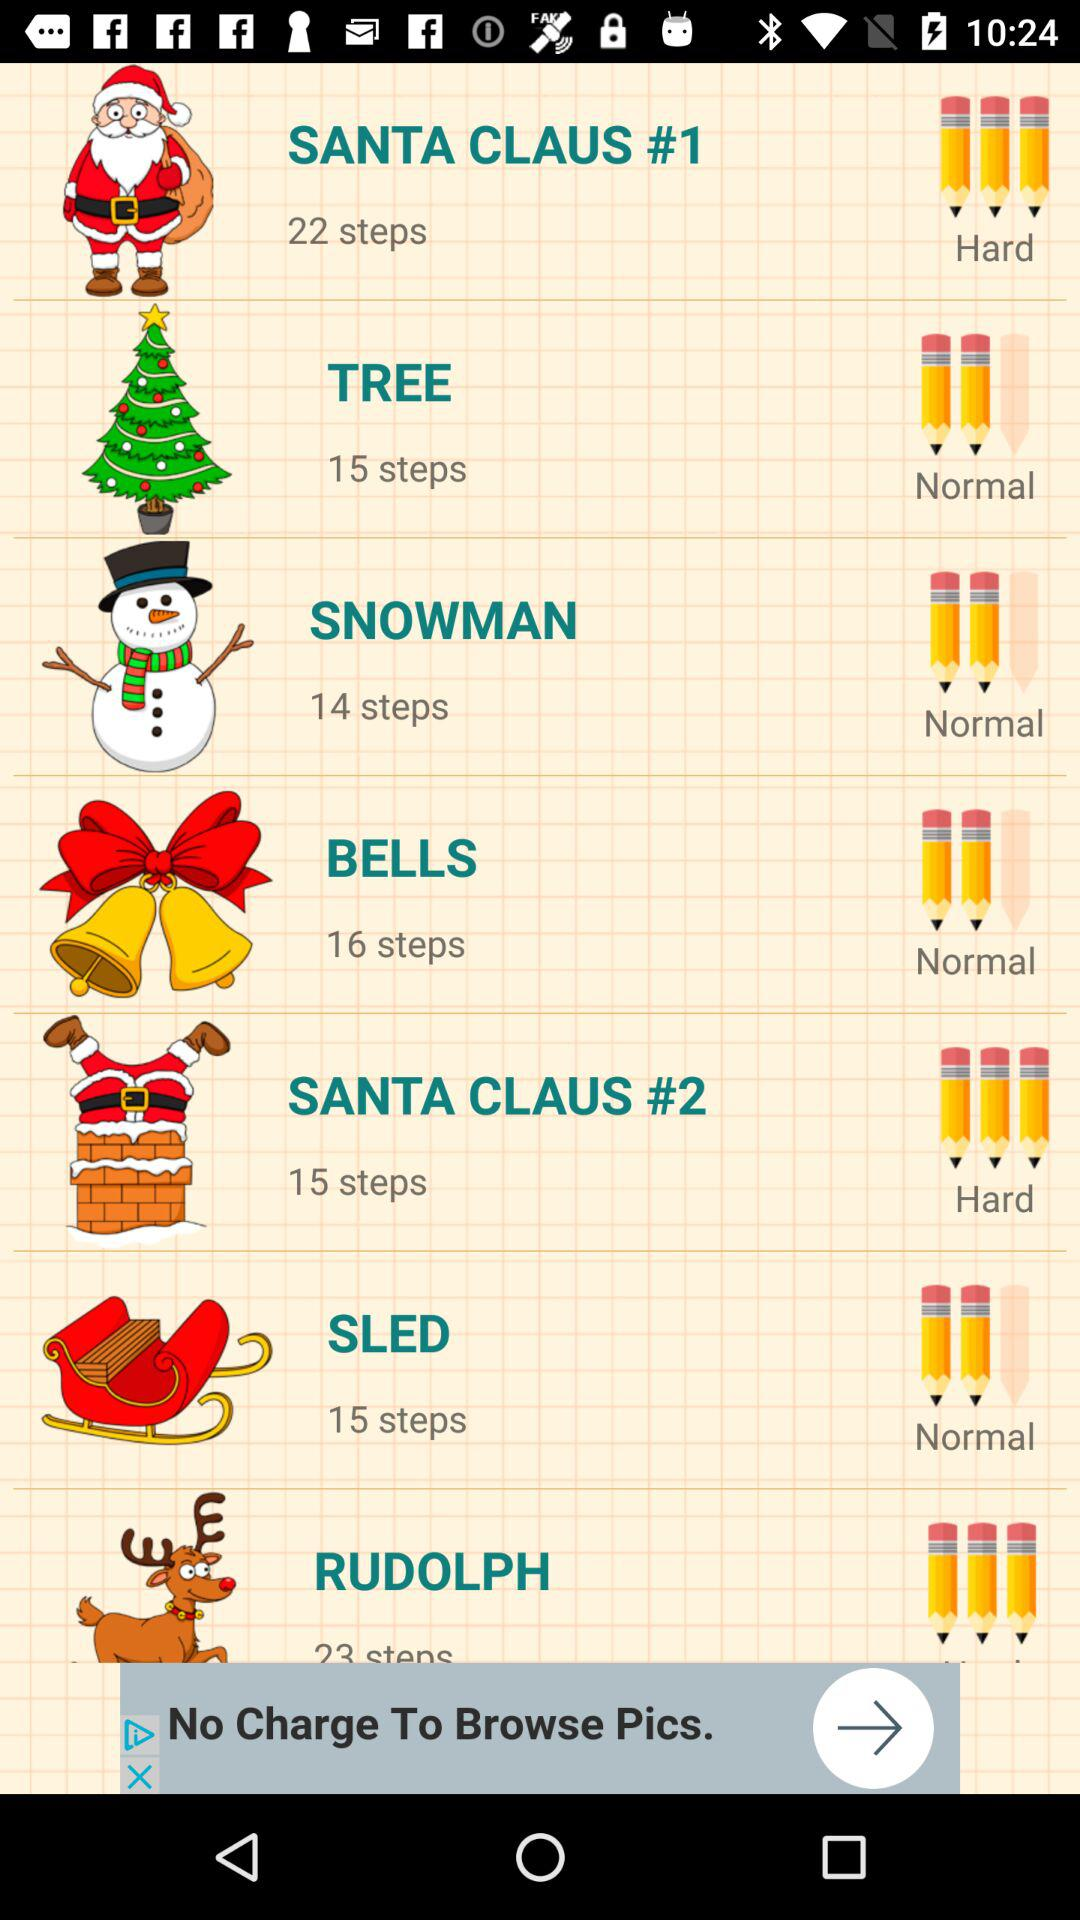How many steps are there for "SLED"? There are 15 steps for "SLED". 